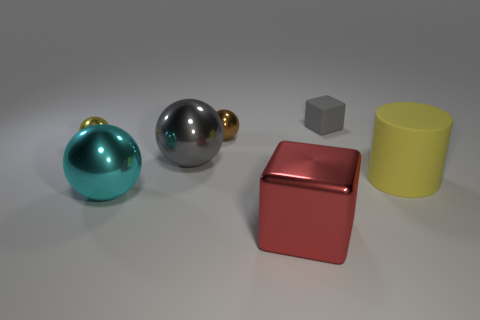Add 3 brown rubber cubes. How many objects exist? 10 Subtract all balls. How many objects are left? 3 Add 3 matte blocks. How many matte blocks exist? 4 Subtract 1 red cubes. How many objects are left? 6 Subtract all tiny cubes. Subtract all brown metallic things. How many objects are left? 5 Add 2 small yellow metal things. How many small yellow metal things are left? 3 